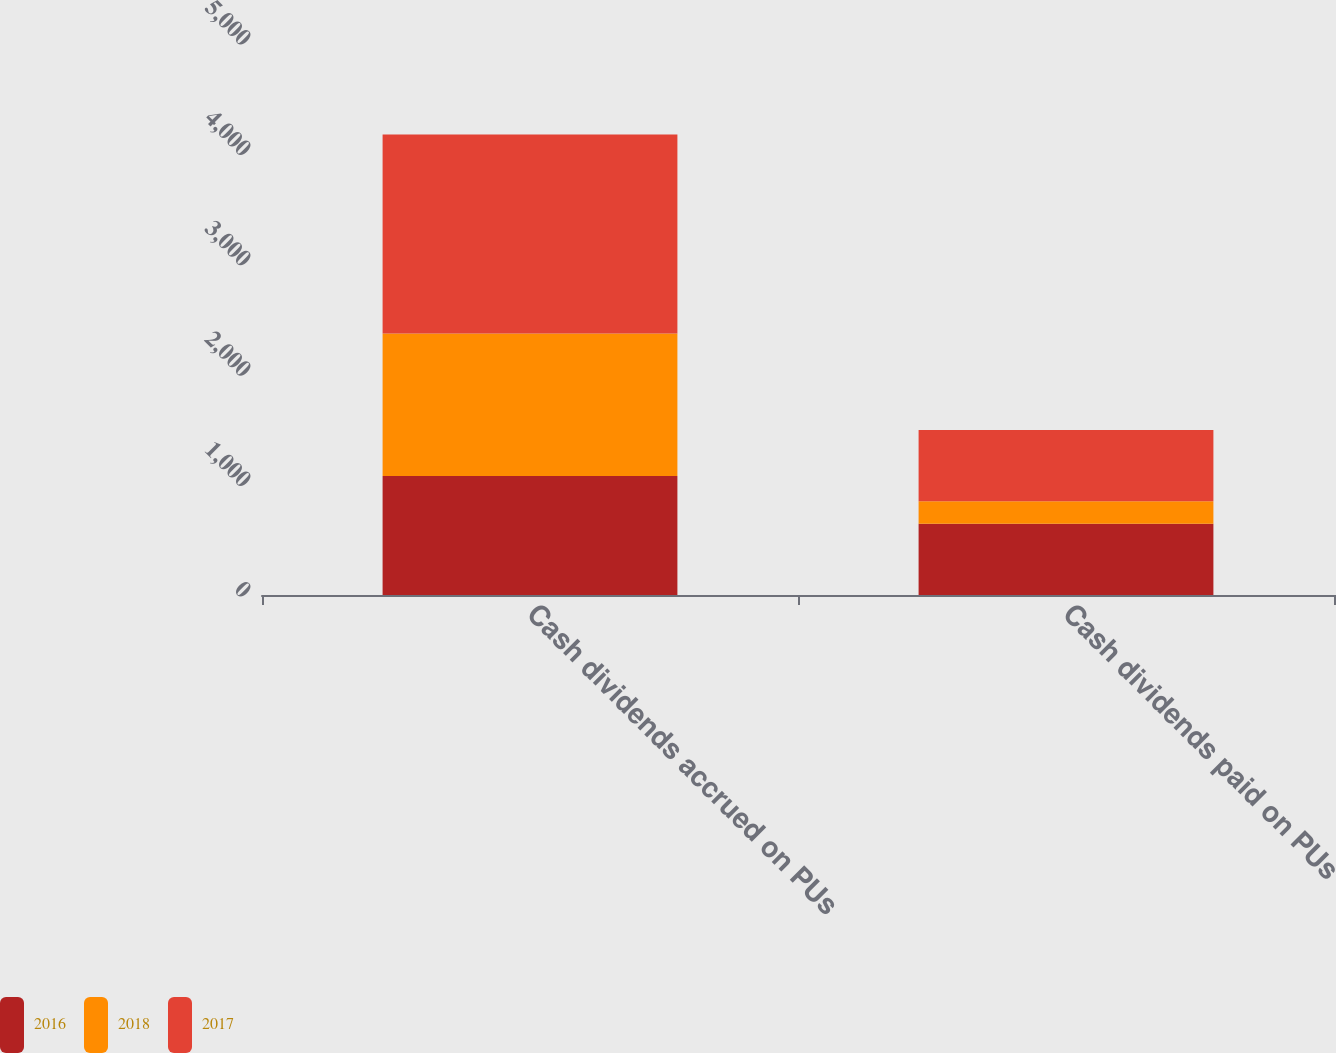<chart> <loc_0><loc_0><loc_500><loc_500><stacked_bar_chart><ecel><fcel>Cash dividends accrued on PUs<fcel>Cash dividends paid on PUs<nl><fcel>2016<fcel>1078<fcel>645<nl><fcel>2018<fcel>1290<fcel>205<nl><fcel>2017<fcel>1804<fcel>644<nl></chart> 